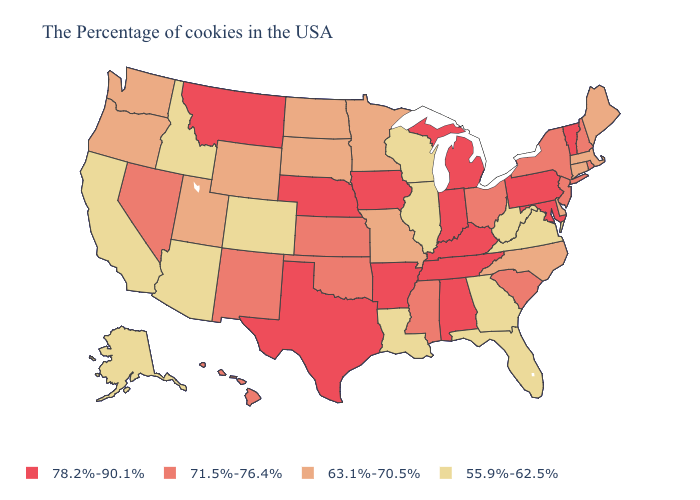What is the highest value in the USA?
Short answer required. 78.2%-90.1%. Which states have the lowest value in the Northeast?
Keep it brief. Maine, Massachusetts, Connecticut. Does West Virginia have the lowest value in the USA?
Answer briefly. Yes. Name the states that have a value in the range 78.2%-90.1%?
Give a very brief answer. Vermont, Maryland, Pennsylvania, Michigan, Kentucky, Indiana, Alabama, Tennessee, Arkansas, Iowa, Nebraska, Texas, Montana. Does South Carolina have a higher value than New Jersey?
Keep it brief. No. Name the states that have a value in the range 71.5%-76.4%?
Give a very brief answer. Rhode Island, New Hampshire, New York, New Jersey, South Carolina, Ohio, Mississippi, Kansas, Oklahoma, New Mexico, Nevada, Hawaii. What is the highest value in the South ?
Answer briefly. 78.2%-90.1%. Name the states that have a value in the range 78.2%-90.1%?
Write a very short answer. Vermont, Maryland, Pennsylvania, Michigan, Kentucky, Indiana, Alabama, Tennessee, Arkansas, Iowa, Nebraska, Texas, Montana. Does Montana have the highest value in the West?
Quick response, please. Yes. Does the map have missing data?
Quick response, please. No. What is the value of North Carolina?
Keep it brief. 63.1%-70.5%. What is the lowest value in the West?
Be succinct. 55.9%-62.5%. Does Oregon have a higher value than Utah?
Keep it brief. No. What is the lowest value in states that border Michigan?
Quick response, please. 55.9%-62.5%. Does Oregon have the highest value in the USA?
Be succinct. No. 